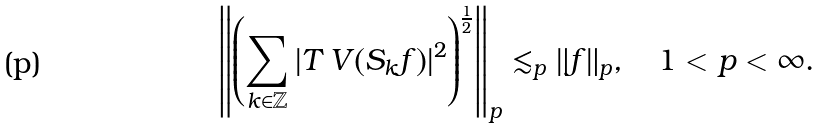Convert formula to latex. <formula><loc_0><loc_0><loc_500><loc_500>\left \| \left ( \sum _ { k \in \mathbb { Z } } | T _ { \ } V ( S _ { k } f ) | ^ { 2 } \right ) ^ { \frac { 1 } { 2 } } \right \| _ { p } \lesssim _ { p } \| f \| _ { p } , \quad 1 < p < \infty .</formula> 